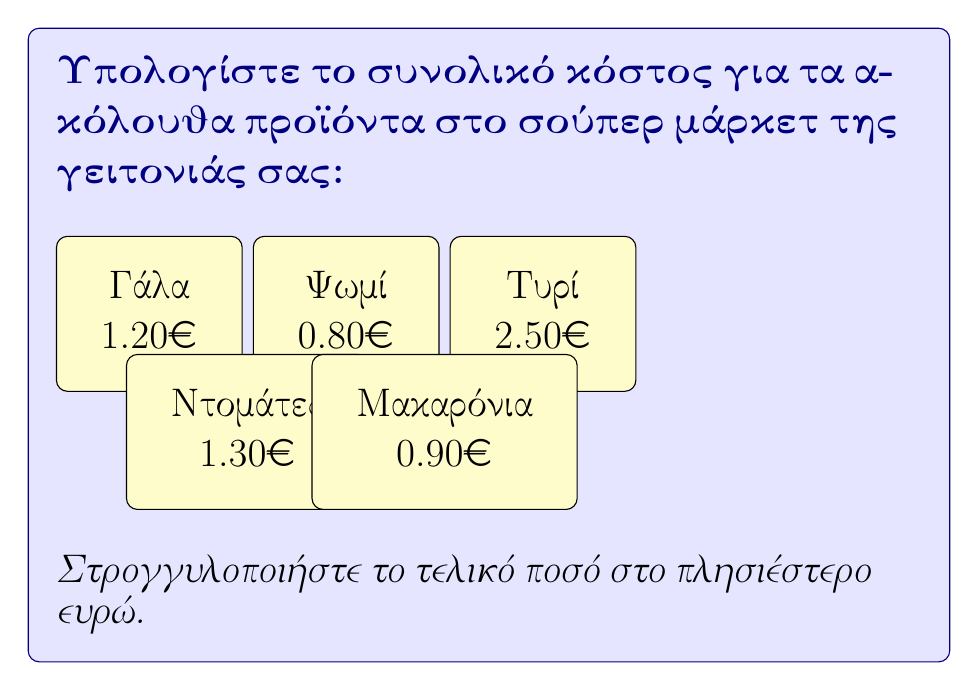Help me with this question. Ας υπολογίσουμε το κόστος βήμα-βήμα:

1) Πρώτα, ας προσθέσουμε τις τιμές όλων των προϊόντων:
   
   Γάλα: $1.20€$
   Ψωμί: $0.80€$
   Τυρί: $2.50€$
   Ντομάτες: $1.30€$
   Μακαρόνια: $0.90€$

2) Το σύνολο είναι:
   $1.20 + 0.80 + 2.50 + 1.30 + 0.90 = 6.70€$

3) Μας ζητήθηκε να στρογγυλοποιήσουμε στο πλησιέστερο ευρώ.
   Το $6.70€$ είναι πιο κοντά στο $7€$ παρά στο $6€$.

Επομένως, το τελικό στρογγυλοποιημένο ποσό είναι $7€$.
Answer: $7€$ 